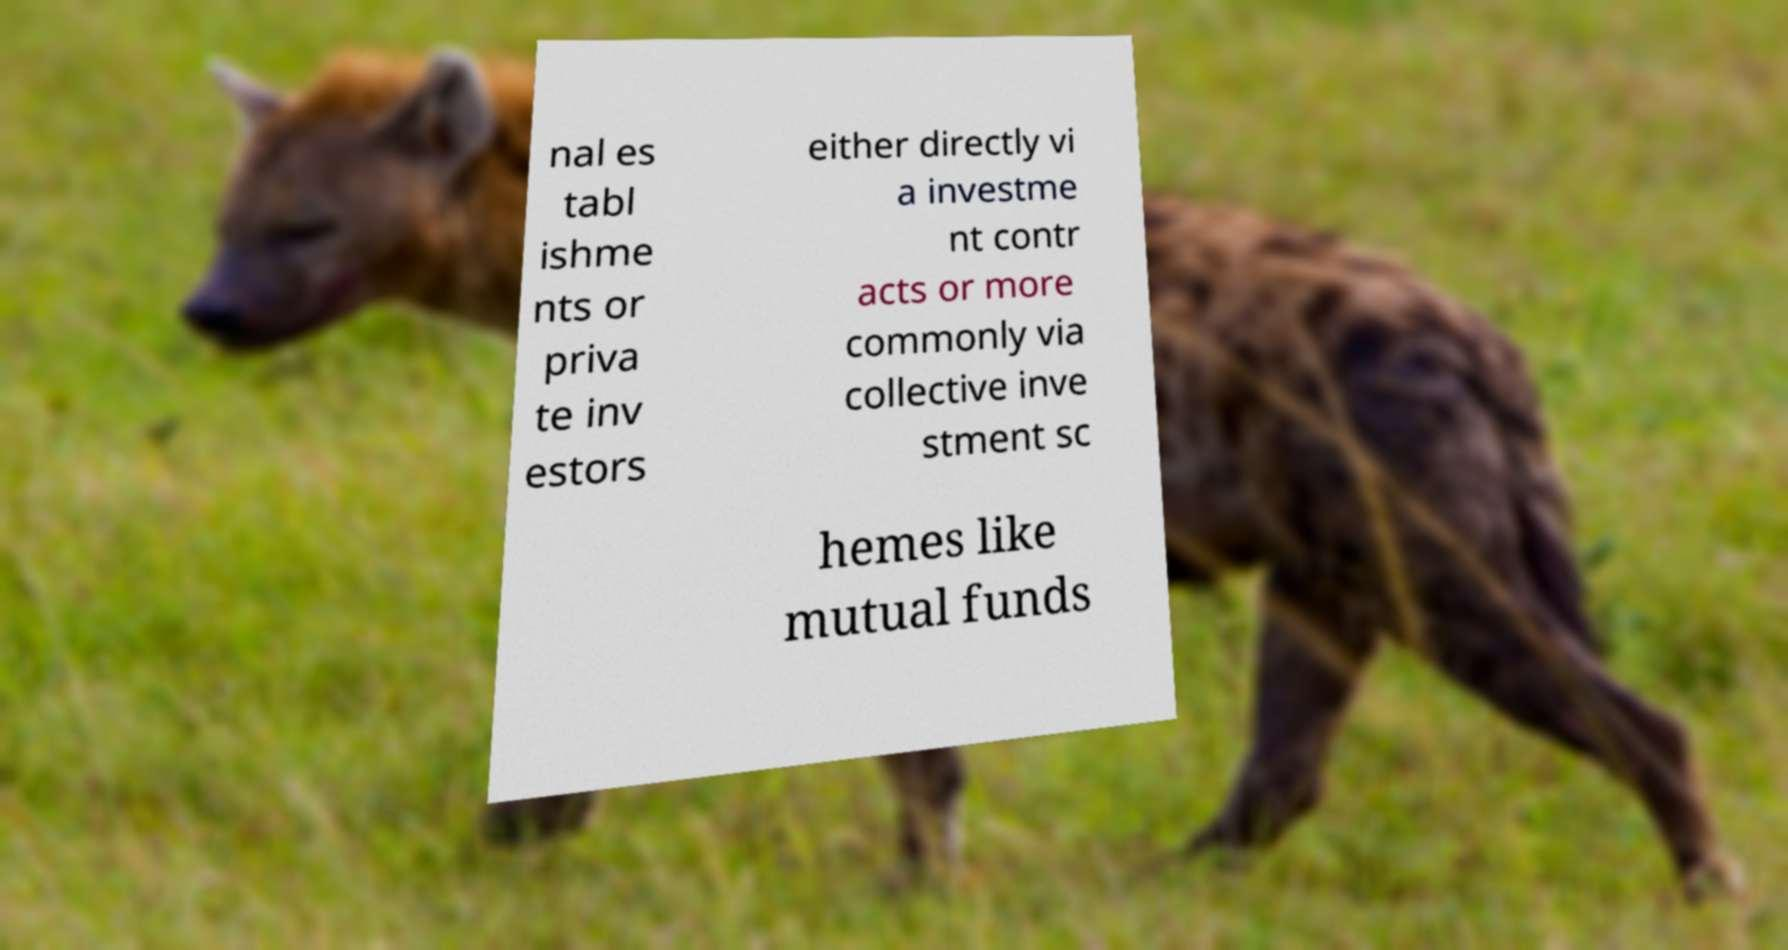For documentation purposes, I need the text within this image transcribed. Could you provide that? nal es tabl ishme nts or priva te inv estors either directly vi a investme nt contr acts or more commonly via collective inve stment sc hemes like mutual funds 